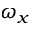Convert formula to latex. <formula><loc_0><loc_0><loc_500><loc_500>\omega _ { x }</formula> 